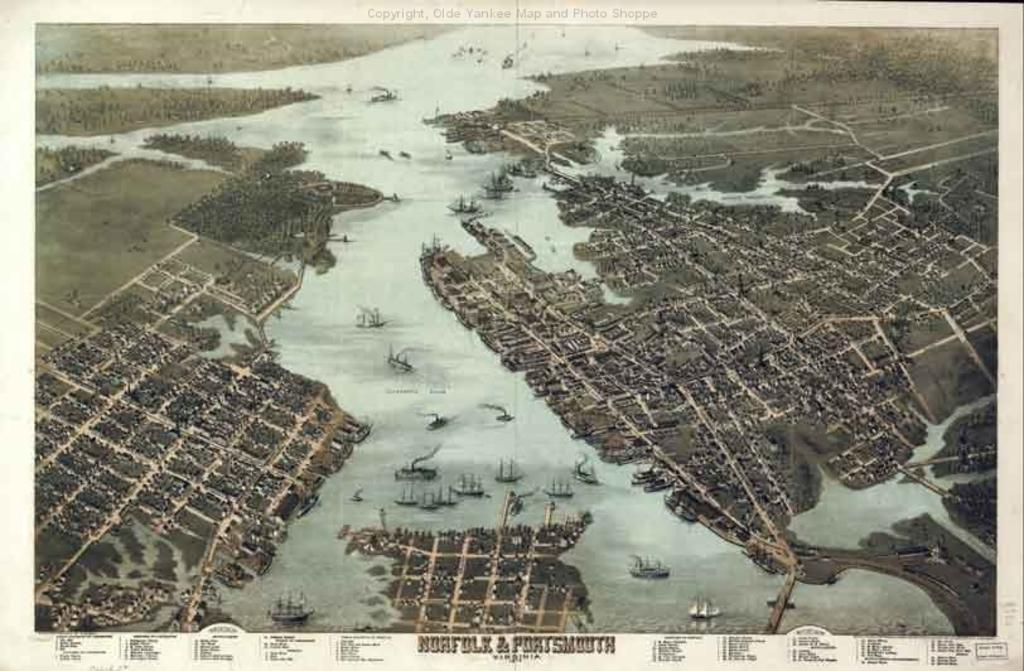What type of visual is the image? The image is a poster. What natural elements are present in the image? There are trees and water in the image. What man-made objects can be seen in the image? There are boats in the image. Is there any text present in the image? Yes, there is text at the bottom of the image. How many beads are strung together in the image? There are no beads present in the image. What type of wood is used to construct the boats in the image? There is no information about the type of wood used to construct the boats in the image. 